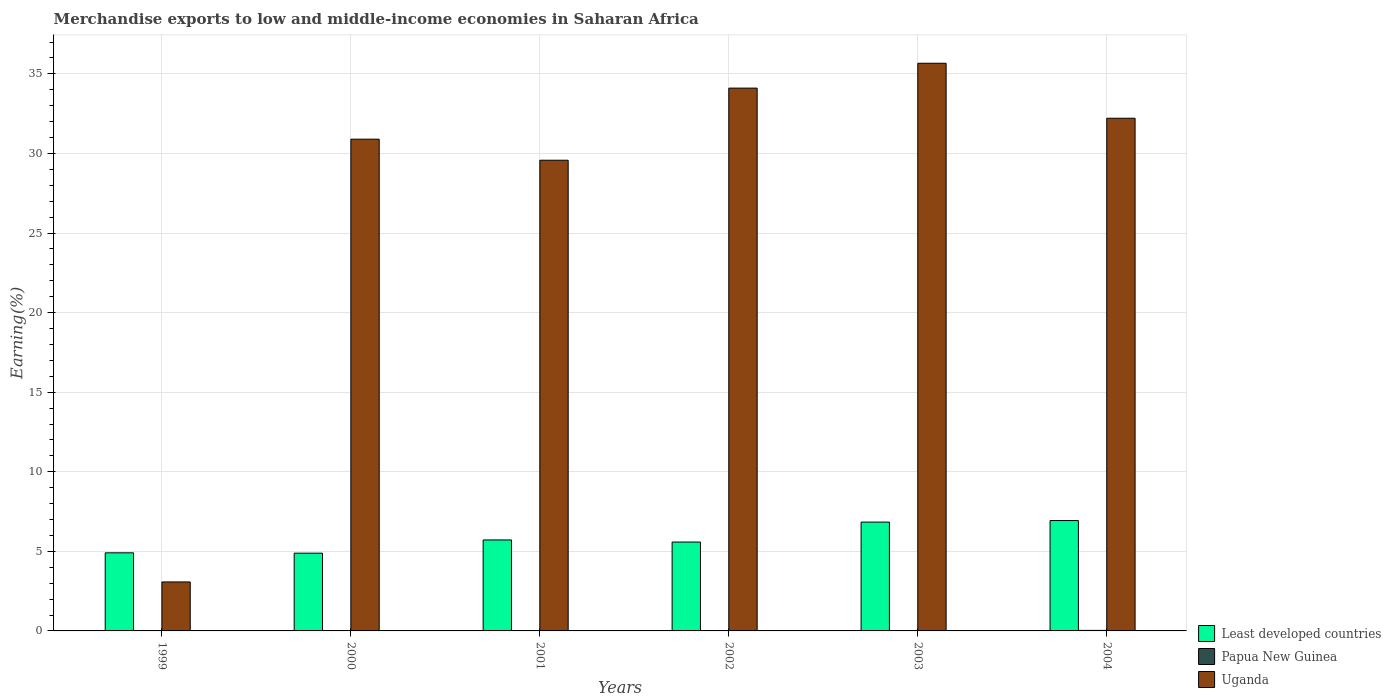How many bars are there on the 6th tick from the right?
Offer a very short reply. 3. What is the percentage of amount earned from merchandise exports in Uganda in 2004?
Give a very brief answer. 32.21. Across all years, what is the maximum percentage of amount earned from merchandise exports in Papua New Guinea?
Offer a very short reply. 0.03. Across all years, what is the minimum percentage of amount earned from merchandise exports in Least developed countries?
Your response must be concise. 4.89. What is the total percentage of amount earned from merchandise exports in Least developed countries in the graph?
Provide a short and direct response. 34.86. What is the difference between the percentage of amount earned from merchandise exports in Least developed countries in 2000 and that in 2003?
Offer a very short reply. -1.95. What is the difference between the percentage of amount earned from merchandise exports in Uganda in 2000 and the percentage of amount earned from merchandise exports in Papua New Guinea in 2002?
Your response must be concise. 30.89. What is the average percentage of amount earned from merchandise exports in Least developed countries per year?
Give a very brief answer. 5.81. In the year 2000, what is the difference between the percentage of amount earned from merchandise exports in Uganda and percentage of amount earned from merchandise exports in Least developed countries?
Ensure brevity in your answer.  26.01. What is the ratio of the percentage of amount earned from merchandise exports in Least developed countries in 1999 to that in 2000?
Your response must be concise. 1. What is the difference between the highest and the second highest percentage of amount earned from merchandise exports in Uganda?
Make the answer very short. 1.56. What is the difference between the highest and the lowest percentage of amount earned from merchandise exports in Least developed countries?
Your response must be concise. 2.05. In how many years, is the percentage of amount earned from merchandise exports in Least developed countries greater than the average percentage of amount earned from merchandise exports in Least developed countries taken over all years?
Offer a very short reply. 2. Is the sum of the percentage of amount earned from merchandise exports in Least developed countries in 2002 and 2003 greater than the maximum percentage of amount earned from merchandise exports in Papua New Guinea across all years?
Provide a succinct answer. Yes. What does the 3rd bar from the left in 2004 represents?
Provide a short and direct response. Uganda. What does the 2nd bar from the right in 1999 represents?
Give a very brief answer. Papua New Guinea. Is it the case that in every year, the sum of the percentage of amount earned from merchandise exports in Least developed countries and percentage of amount earned from merchandise exports in Uganda is greater than the percentage of amount earned from merchandise exports in Papua New Guinea?
Make the answer very short. Yes. Are all the bars in the graph horizontal?
Ensure brevity in your answer.  No. What is the difference between two consecutive major ticks on the Y-axis?
Ensure brevity in your answer.  5. Does the graph contain any zero values?
Provide a succinct answer. No. Where does the legend appear in the graph?
Your answer should be compact. Bottom right. What is the title of the graph?
Your answer should be very brief. Merchandise exports to low and middle-income economies in Saharan Africa. What is the label or title of the Y-axis?
Your answer should be compact. Earning(%). What is the Earning(%) of Least developed countries in 1999?
Your answer should be compact. 4.91. What is the Earning(%) of Papua New Guinea in 1999?
Your answer should be very brief. 0. What is the Earning(%) of Uganda in 1999?
Provide a succinct answer. 3.08. What is the Earning(%) in Least developed countries in 2000?
Make the answer very short. 4.89. What is the Earning(%) of Papua New Guinea in 2000?
Your answer should be very brief. 0. What is the Earning(%) in Uganda in 2000?
Provide a short and direct response. 30.9. What is the Earning(%) of Least developed countries in 2001?
Offer a terse response. 5.72. What is the Earning(%) in Papua New Guinea in 2001?
Offer a very short reply. 0. What is the Earning(%) in Uganda in 2001?
Give a very brief answer. 29.57. What is the Earning(%) of Least developed countries in 2002?
Ensure brevity in your answer.  5.58. What is the Earning(%) in Papua New Guinea in 2002?
Make the answer very short. 0. What is the Earning(%) in Uganda in 2002?
Offer a very short reply. 34.1. What is the Earning(%) of Least developed countries in 2003?
Keep it short and to the point. 6.84. What is the Earning(%) in Papua New Guinea in 2003?
Your answer should be very brief. 0.01. What is the Earning(%) in Uganda in 2003?
Offer a terse response. 35.67. What is the Earning(%) of Least developed countries in 2004?
Offer a terse response. 6.93. What is the Earning(%) of Papua New Guinea in 2004?
Your answer should be very brief. 0.03. What is the Earning(%) of Uganda in 2004?
Offer a very short reply. 32.21. Across all years, what is the maximum Earning(%) of Least developed countries?
Provide a short and direct response. 6.93. Across all years, what is the maximum Earning(%) in Papua New Guinea?
Your answer should be compact. 0.03. Across all years, what is the maximum Earning(%) in Uganda?
Give a very brief answer. 35.67. Across all years, what is the minimum Earning(%) in Least developed countries?
Provide a short and direct response. 4.89. Across all years, what is the minimum Earning(%) of Papua New Guinea?
Offer a very short reply. 0. Across all years, what is the minimum Earning(%) in Uganda?
Offer a terse response. 3.08. What is the total Earning(%) in Least developed countries in the graph?
Offer a terse response. 34.86. What is the total Earning(%) of Papua New Guinea in the graph?
Keep it short and to the point. 0.06. What is the total Earning(%) in Uganda in the graph?
Ensure brevity in your answer.  165.53. What is the difference between the Earning(%) in Least developed countries in 1999 and that in 2000?
Ensure brevity in your answer.  0.02. What is the difference between the Earning(%) of Papua New Guinea in 1999 and that in 2000?
Give a very brief answer. 0. What is the difference between the Earning(%) in Uganda in 1999 and that in 2000?
Your response must be concise. -27.82. What is the difference between the Earning(%) in Least developed countries in 1999 and that in 2001?
Offer a very short reply. -0.81. What is the difference between the Earning(%) of Papua New Guinea in 1999 and that in 2001?
Give a very brief answer. 0. What is the difference between the Earning(%) of Uganda in 1999 and that in 2001?
Your response must be concise. -26.5. What is the difference between the Earning(%) in Least developed countries in 1999 and that in 2002?
Offer a terse response. -0.68. What is the difference between the Earning(%) of Papua New Guinea in 1999 and that in 2002?
Offer a very short reply. 0. What is the difference between the Earning(%) of Uganda in 1999 and that in 2002?
Provide a succinct answer. -31.03. What is the difference between the Earning(%) in Least developed countries in 1999 and that in 2003?
Your answer should be compact. -1.93. What is the difference between the Earning(%) of Papua New Guinea in 1999 and that in 2003?
Give a very brief answer. -0.01. What is the difference between the Earning(%) in Uganda in 1999 and that in 2003?
Give a very brief answer. -32.59. What is the difference between the Earning(%) in Least developed countries in 1999 and that in 2004?
Offer a very short reply. -2.03. What is the difference between the Earning(%) of Papua New Guinea in 1999 and that in 2004?
Provide a short and direct response. -0.03. What is the difference between the Earning(%) in Uganda in 1999 and that in 2004?
Keep it short and to the point. -29.13. What is the difference between the Earning(%) of Least developed countries in 2000 and that in 2001?
Keep it short and to the point. -0.83. What is the difference between the Earning(%) in Papua New Guinea in 2000 and that in 2001?
Your answer should be compact. -0. What is the difference between the Earning(%) in Uganda in 2000 and that in 2001?
Give a very brief answer. 1.32. What is the difference between the Earning(%) of Least developed countries in 2000 and that in 2002?
Give a very brief answer. -0.7. What is the difference between the Earning(%) in Papua New Guinea in 2000 and that in 2002?
Provide a short and direct response. -0. What is the difference between the Earning(%) of Uganda in 2000 and that in 2002?
Offer a very short reply. -3.21. What is the difference between the Earning(%) in Least developed countries in 2000 and that in 2003?
Give a very brief answer. -1.95. What is the difference between the Earning(%) in Papua New Guinea in 2000 and that in 2003?
Provide a short and direct response. -0.01. What is the difference between the Earning(%) in Uganda in 2000 and that in 2003?
Keep it short and to the point. -4.77. What is the difference between the Earning(%) in Least developed countries in 2000 and that in 2004?
Ensure brevity in your answer.  -2.05. What is the difference between the Earning(%) of Papua New Guinea in 2000 and that in 2004?
Ensure brevity in your answer.  -0.03. What is the difference between the Earning(%) in Uganda in 2000 and that in 2004?
Keep it short and to the point. -1.31. What is the difference between the Earning(%) in Least developed countries in 2001 and that in 2002?
Provide a short and direct response. 0.13. What is the difference between the Earning(%) of Papua New Guinea in 2001 and that in 2002?
Offer a very short reply. 0. What is the difference between the Earning(%) in Uganda in 2001 and that in 2002?
Ensure brevity in your answer.  -4.53. What is the difference between the Earning(%) in Least developed countries in 2001 and that in 2003?
Offer a very short reply. -1.12. What is the difference between the Earning(%) of Papua New Guinea in 2001 and that in 2003?
Provide a succinct answer. -0.01. What is the difference between the Earning(%) in Uganda in 2001 and that in 2003?
Ensure brevity in your answer.  -6.09. What is the difference between the Earning(%) in Least developed countries in 2001 and that in 2004?
Offer a terse response. -1.22. What is the difference between the Earning(%) of Papua New Guinea in 2001 and that in 2004?
Give a very brief answer. -0.03. What is the difference between the Earning(%) in Uganda in 2001 and that in 2004?
Make the answer very short. -2.64. What is the difference between the Earning(%) of Least developed countries in 2002 and that in 2003?
Give a very brief answer. -1.25. What is the difference between the Earning(%) in Papua New Guinea in 2002 and that in 2003?
Provide a succinct answer. -0.01. What is the difference between the Earning(%) of Uganda in 2002 and that in 2003?
Your answer should be compact. -1.56. What is the difference between the Earning(%) in Least developed countries in 2002 and that in 2004?
Ensure brevity in your answer.  -1.35. What is the difference between the Earning(%) in Papua New Guinea in 2002 and that in 2004?
Provide a succinct answer. -0.03. What is the difference between the Earning(%) in Uganda in 2002 and that in 2004?
Keep it short and to the point. 1.89. What is the difference between the Earning(%) in Least developed countries in 2003 and that in 2004?
Ensure brevity in your answer.  -0.1. What is the difference between the Earning(%) in Papua New Guinea in 2003 and that in 2004?
Offer a terse response. -0.02. What is the difference between the Earning(%) of Uganda in 2003 and that in 2004?
Ensure brevity in your answer.  3.45. What is the difference between the Earning(%) in Least developed countries in 1999 and the Earning(%) in Papua New Guinea in 2000?
Offer a terse response. 4.91. What is the difference between the Earning(%) of Least developed countries in 1999 and the Earning(%) of Uganda in 2000?
Offer a terse response. -25.99. What is the difference between the Earning(%) in Papua New Guinea in 1999 and the Earning(%) in Uganda in 2000?
Give a very brief answer. -30.89. What is the difference between the Earning(%) of Least developed countries in 1999 and the Earning(%) of Papua New Guinea in 2001?
Your response must be concise. 4.9. What is the difference between the Earning(%) in Least developed countries in 1999 and the Earning(%) in Uganda in 2001?
Make the answer very short. -24.67. What is the difference between the Earning(%) of Papua New Guinea in 1999 and the Earning(%) of Uganda in 2001?
Make the answer very short. -29.57. What is the difference between the Earning(%) in Least developed countries in 1999 and the Earning(%) in Papua New Guinea in 2002?
Ensure brevity in your answer.  4.91. What is the difference between the Earning(%) in Least developed countries in 1999 and the Earning(%) in Uganda in 2002?
Keep it short and to the point. -29.2. What is the difference between the Earning(%) of Papua New Guinea in 1999 and the Earning(%) of Uganda in 2002?
Ensure brevity in your answer.  -34.1. What is the difference between the Earning(%) in Least developed countries in 1999 and the Earning(%) in Papua New Guinea in 2003?
Give a very brief answer. 4.89. What is the difference between the Earning(%) of Least developed countries in 1999 and the Earning(%) of Uganda in 2003?
Provide a short and direct response. -30.76. What is the difference between the Earning(%) of Papua New Guinea in 1999 and the Earning(%) of Uganda in 2003?
Your response must be concise. -35.66. What is the difference between the Earning(%) in Least developed countries in 1999 and the Earning(%) in Papua New Guinea in 2004?
Offer a terse response. 4.87. What is the difference between the Earning(%) in Least developed countries in 1999 and the Earning(%) in Uganda in 2004?
Your response must be concise. -27.3. What is the difference between the Earning(%) in Papua New Guinea in 1999 and the Earning(%) in Uganda in 2004?
Offer a very short reply. -32.21. What is the difference between the Earning(%) in Least developed countries in 2000 and the Earning(%) in Papua New Guinea in 2001?
Provide a short and direct response. 4.88. What is the difference between the Earning(%) of Least developed countries in 2000 and the Earning(%) of Uganda in 2001?
Offer a terse response. -24.69. What is the difference between the Earning(%) in Papua New Guinea in 2000 and the Earning(%) in Uganda in 2001?
Keep it short and to the point. -29.57. What is the difference between the Earning(%) of Least developed countries in 2000 and the Earning(%) of Papua New Guinea in 2002?
Provide a succinct answer. 4.88. What is the difference between the Earning(%) in Least developed countries in 2000 and the Earning(%) in Uganda in 2002?
Provide a succinct answer. -29.22. What is the difference between the Earning(%) in Papua New Guinea in 2000 and the Earning(%) in Uganda in 2002?
Give a very brief answer. -34.1. What is the difference between the Earning(%) of Least developed countries in 2000 and the Earning(%) of Papua New Guinea in 2003?
Keep it short and to the point. 4.87. What is the difference between the Earning(%) of Least developed countries in 2000 and the Earning(%) of Uganda in 2003?
Provide a succinct answer. -30.78. What is the difference between the Earning(%) in Papua New Guinea in 2000 and the Earning(%) in Uganda in 2003?
Your answer should be very brief. -35.67. What is the difference between the Earning(%) of Least developed countries in 2000 and the Earning(%) of Papua New Guinea in 2004?
Your answer should be compact. 4.85. What is the difference between the Earning(%) of Least developed countries in 2000 and the Earning(%) of Uganda in 2004?
Provide a succinct answer. -27.33. What is the difference between the Earning(%) of Papua New Guinea in 2000 and the Earning(%) of Uganda in 2004?
Your response must be concise. -32.21. What is the difference between the Earning(%) of Least developed countries in 2001 and the Earning(%) of Papua New Guinea in 2002?
Keep it short and to the point. 5.71. What is the difference between the Earning(%) of Least developed countries in 2001 and the Earning(%) of Uganda in 2002?
Provide a short and direct response. -28.39. What is the difference between the Earning(%) in Papua New Guinea in 2001 and the Earning(%) in Uganda in 2002?
Provide a short and direct response. -34.1. What is the difference between the Earning(%) in Least developed countries in 2001 and the Earning(%) in Papua New Guinea in 2003?
Make the answer very short. 5.7. What is the difference between the Earning(%) in Least developed countries in 2001 and the Earning(%) in Uganda in 2003?
Offer a terse response. -29.95. What is the difference between the Earning(%) of Papua New Guinea in 2001 and the Earning(%) of Uganda in 2003?
Ensure brevity in your answer.  -35.66. What is the difference between the Earning(%) in Least developed countries in 2001 and the Earning(%) in Papua New Guinea in 2004?
Offer a terse response. 5.68. What is the difference between the Earning(%) of Least developed countries in 2001 and the Earning(%) of Uganda in 2004?
Offer a terse response. -26.5. What is the difference between the Earning(%) in Papua New Guinea in 2001 and the Earning(%) in Uganda in 2004?
Your response must be concise. -32.21. What is the difference between the Earning(%) in Least developed countries in 2002 and the Earning(%) in Papua New Guinea in 2003?
Offer a terse response. 5.57. What is the difference between the Earning(%) of Least developed countries in 2002 and the Earning(%) of Uganda in 2003?
Give a very brief answer. -30.08. What is the difference between the Earning(%) of Papua New Guinea in 2002 and the Earning(%) of Uganda in 2003?
Your response must be concise. -35.66. What is the difference between the Earning(%) in Least developed countries in 2002 and the Earning(%) in Papua New Guinea in 2004?
Offer a very short reply. 5.55. What is the difference between the Earning(%) of Least developed countries in 2002 and the Earning(%) of Uganda in 2004?
Provide a succinct answer. -26.63. What is the difference between the Earning(%) of Papua New Guinea in 2002 and the Earning(%) of Uganda in 2004?
Your response must be concise. -32.21. What is the difference between the Earning(%) in Least developed countries in 2003 and the Earning(%) in Papua New Guinea in 2004?
Provide a short and direct response. 6.8. What is the difference between the Earning(%) of Least developed countries in 2003 and the Earning(%) of Uganda in 2004?
Ensure brevity in your answer.  -25.37. What is the difference between the Earning(%) in Papua New Guinea in 2003 and the Earning(%) in Uganda in 2004?
Your answer should be compact. -32.2. What is the average Earning(%) in Least developed countries per year?
Provide a short and direct response. 5.81. What is the average Earning(%) in Papua New Guinea per year?
Make the answer very short. 0.01. What is the average Earning(%) in Uganda per year?
Offer a terse response. 27.59. In the year 1999, what is the difference between the Earning(%) in Least developed countries and Earning(%) in Papua New Guinea?
Provide a short and direct response. 4.9. In the year 1999, what is the difference between the Earning(%) of Least developed countries and Earning(%) of Uganda?
Offer a very short reply. 1.83. In the year 1999, what is the difference between the Earning(%) in Papua New Guinea and Earning(%) in Uganda?
Your answer should be very brief. -3.07. In the year 2000, what is the difference between the Earning(%) of Least developed countries and Earning(%) of Papua New Guinea?
Provide a succinct answer. 4.89. In the year 2000, what is the difference between the Earning(%) of Least developed countries and Earning(%) of Uganda?
Ensure brevity in your answer.  -26.01. In the year 2000, what is the difference between the Earning(%) of Papua New Guinea and Earning(%) of Uganda?
Ensure brevity in your answer.  -30.9. In the year 2001, what is the difference between the Earning(%) of Least developed countries and Earning(%) of Papua New Guinea?
Your answer should be very brief. 5.71. In the year 2001, what is the difference between the Earning(%) of Least developed countries and Earning(%) of Uganda?
Offer a very short reply. -23.86. In the year 2001, what is the difference between the Earning(%) in Papua New Guinea and Earning(%) in Uganda?
Provide a succinct answer. -29.57. In the year 2002, what is the difference between the Earning(%) of Least developed countries and Earning(%) of Papua New Guinea?
Offer a very short reply. 5.58. In the year 2002, what is the difference between the Earning(%) of Least developed countries and Earning(%) of Uganda?
Make the answer very short. -28.52. In the year 2002, what is the difference between the Earning(%) in Papua New Guinea and Earning(%) in Uganda?
Ensure brevity in your answer.  -34.1. In the year 2003, what is the difference between the Earning(%) of Least developed countries and Earning(%) of Papua New Guinea?
Provide a short and direct response. 6.82. In the year 2003, what is the difference between the Earning(%) in Least developed countries and Earning(%) in Uganda?
Ensure brevity in your answer.  -28.83. In the year 2003, what is the difference between the Earning(%) of Papua New Guinea and Earning(%) of Uganda?
Provide a short and direct response. -35.65. In the year 2004, what is the difference between the Earning(%) in Least developed countries and Earning(%) in Papua New Guinea?
Ensure brevity in your answer.  6.9. In the year 2004, what is the difference between the Earning(%) in Least developed countries and Earning(%) in Uganda?
Keep it short and to the point. -25.28. In the year 2004, what is the difference between the Earning(%) in Papua New Guinea and Earning(%) in Uganda?
Your answer should be compact. -32.18. What is the ratio of the Earning(%) in Papua New Guinea in 1999 to that in 2000?
Provide a short and direct response. 31.26. What is the ratio of the Earning(%) in Uganda in 1999 to that in 2000?
Offer a terse response. 0.1. What is the ratio of the Earning(%) of Least developed countries in 1999 to that in 2001?
Your response must be concise. 0.86. What is the ratio of the Earning(%) in Papua New Guinea in 1999 to that in 2001?
Keep it short and to the point. 1.01. What is the ratio of the Earning(%) of Uganda in 1999 to that in 2001?
Provide a short and direct response. 0.1. What is the ratio of the Earning(%) in Least developed countries in 1999 to that in 2002?
Make the answer very short. 0.88. What is the ratio of the Earning(%) of Papua New Guinea in 1999 to that in 2002?
Provide a short and direct response. 2.41. What is the ratio of the Earning(%) in Uganda in 1999 to that in 2002?
Offer a very short reply. 0.09. What is the ratio of the Earning(%) of Least developed countries in 1999 to that in 2003?
Your answer should be very brief. 0.72. What is the ratio of the Earning(%) in Papua New Guinea in 1999 to that in 2003?
Keep it short and to the point. 0.29. What is the ratio of the Earning(%) in Uganda in 1999 to that in 2003?
Give a very brief answer. 0.09. What is the ratio of the Earning(%) of Least developed countries in 1999 to that in 2004?
Offer a very short reply. 0.71. What is the ratio of the Earning(%) of Papua New Guinea in 1999 to that in 2004?
Give a very brief answer. 0.13. What is the ratio of the Earning(%) of Uganda in 1999 to that in 2004?
Ensure brevity in your answer.  0.1. What is the ratio of the Earning(%) in Least developed countries in 2000 to that in 2001?
Offer a terse response. 0.85. What is the ratio of the Earning(%) in Papua New Guinea in 2000 to that in 2001?
Your response must be concise. 0.03. What is the ratio of the Earning(%) of Uganda in 2000 to that in 2001?
Give a very brief answer. 1.04. What is the ratio of the Earning(%) in Papua New Guinea in 2000 to that in 2002?
Your response must be concise. 0.08. What is the ratio of the Earning(%) of Uganda in 2000 to that in 2002?
Keep it short and to the point. 0.91. What is the ratio of the Earning(%) in Least developed countries in 2000 to that in 2003?
Your answer should be very brief. 0.71. What is the ratio of the Earning(%) of Papua New Guinea in 2000 to that in 2003?
Offer a very short reply. 0.01. What is the ratio of the Earning(%) in Uganda in 2000 to that in 2003?
Provide a succinct answer. 0.87. What is the ratio of the Earning(%) in Least developed countries in 2000 to that in 2004?
Ensure brevity in your answer.  0.7. What is the ratio of the Earning(%) in Papua New Guinea in 2000 to that in 2004?
Your response must be concise. 0. What is the ratio of the Earning(%) of Uganda in 2000 to that in 2004?
Offer a very short reply. 0.96. What is the ratio of the Earning(%) in Least developed countries in 2001 to that in 2002?
Provide a succinct answer. 1.02. What is the ratio of the Earning(%) of Papua New Guinea in 2001 to that in 2002?
Offer a very short reply. 2.38. What is the ratio of the Earning(%) of Uganda in 2001 to that in 2002?
Offer a terse response. 0.87. What is the ratio of the Earning(%) of Least developed countries in 2001 to that in 2003?
Provide a short and direct response. 0.84. What is the ratio of the Earning(%) in Papua New Guinea in 2001 to that in 2003?
Offer a very short reply. 0.28. What is the ratio of the Earning(%) in Uganda in 2001 to that in 2003?
Provide a short and direct response. 0.83. What is the ratio of the Earning(%) in Least developed countries in 2001 to that in 2004?
Your answer should be very brief. 0.82. What is the ratio of the Earning(%) of Papua New Guinea in 2001 to that in 2004?
Provide a short and direct response. 0.13. What is the ratio of the Earning(%) of Uganda in 2001 to that in 2004?
Give a very brief answer. 0.92. What is the ratio of the Earning(%) in Least developed countries in 2002 to that in 2003?
Ensure brevity in your answer.  0.82. What is the ratio of the Earning(%) in Papua New Guinea in 2002 to that in 2003?
Offer a terse response. 0.12. What is the ratio of the Earning(%) in Uganda in 2002 to that in 2003?
Make the answer very short. 0.96. What is the ratio of the Earning(%) in Least developed countries in 2002 to that in 2004?
Your response must be concise. 0.81. What is the ratio of the Earning(%) of Papua New Guinea in 2002 to that in 2004?
Your answer should be very brief. 0.05. What is the ratio of the Earning(%) in Uganda in 2002 to that in 2004?
Keep it short and to the point. 1.06. What is the ratio of the Earning(%) of Least developed countries in 2003 to that in 2004?
Provide a short and direct response. 0.99. What is the ratio of the Earning(%) of Papua New Guinea in 2003 to that in 2004?
Offer a terse response. 0.44. What is the ratio of the Earning(%) in Uganda in 2003 to that in 2004?
Give a very brief answer. 1.11. What is the difference between the highest and the second highest Earning(%) of Least developed countries?
Provide a short and direct response. 0.1. What is the difference between the highest and the second highest Earning(%) of Papua New Guinea?
Keep it short and to the point. 0.02. What is the difference between the highest and the second highest Earning(%) in Uganda?
Provide a succinct answer. 1.56. What is the difference between the highest and the lowest Earning(%) of Least developed countries?
Give a very brief answer. 2.05. What is the difference between the highest and the lowest Earning(%) of Papua New Guinea?
Give a very brief answer. 0.03. What is the difference between the highest and the lowest Earning(%) of Uganda?
Ensure brevity in your answer.  32.59. 